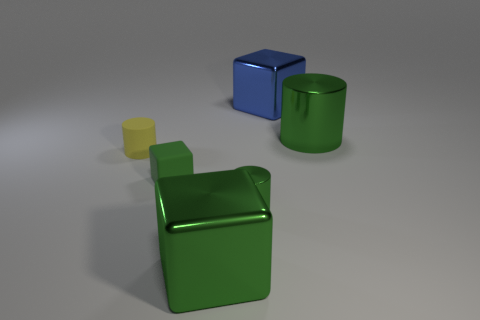There is another green thing that is the same shape as the green rubber object; what is its size?
Ensure brevity in your answer.  Large. How many other objects are there of the same material as the blue object?
Make the answer very short. 3. What is the small green cylinder made of?
Offer a very short reply. Metal. There is a shiny thing left of the small metallic cylinder; is it the same color as the tiny rubber thing that is in front of the tiny yellow matte object?
Your answer should be compact. Yes. Is the number of blue blocks behind the small green matte object greater than the number of purple rubber cylinders?
Provide a short and direct response. Yes. What number of other things are the same color as the tiny shiny cylinder?
Ensure brevity in your answer.  3. Do the green cylinder in front of the yellow cylinder and the tiny yellow object have the same size?
Your answer should be compact. Yes. Is there a yellow cylinder that has the same size as the green rubber block?
Give a very brief answer. Yes. There is a big metal block that is left of the blue metal block; what is its color?
Your response must be concise. Green. What shape is the large shiny object that is to the left of the big metal cylinder and in front of the blue object?
Provide a short and direct response. Cube. 